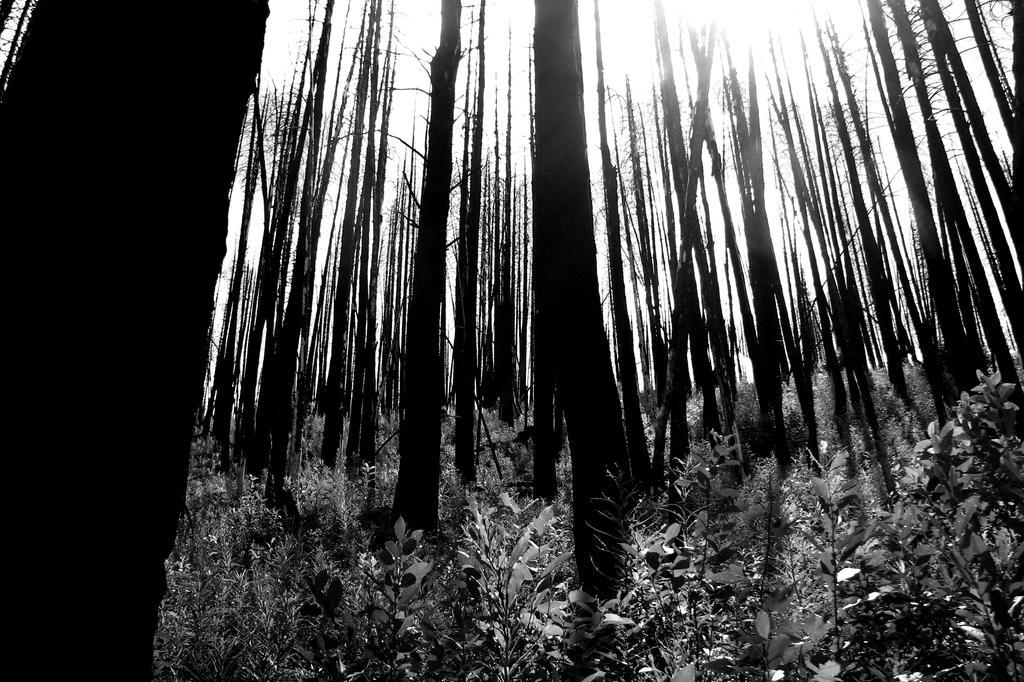In one or two sentences, can you explain what this image depicts? In this picture I can see there are few trees, plants and the sky is clear and sunny. This is a black and white image. 